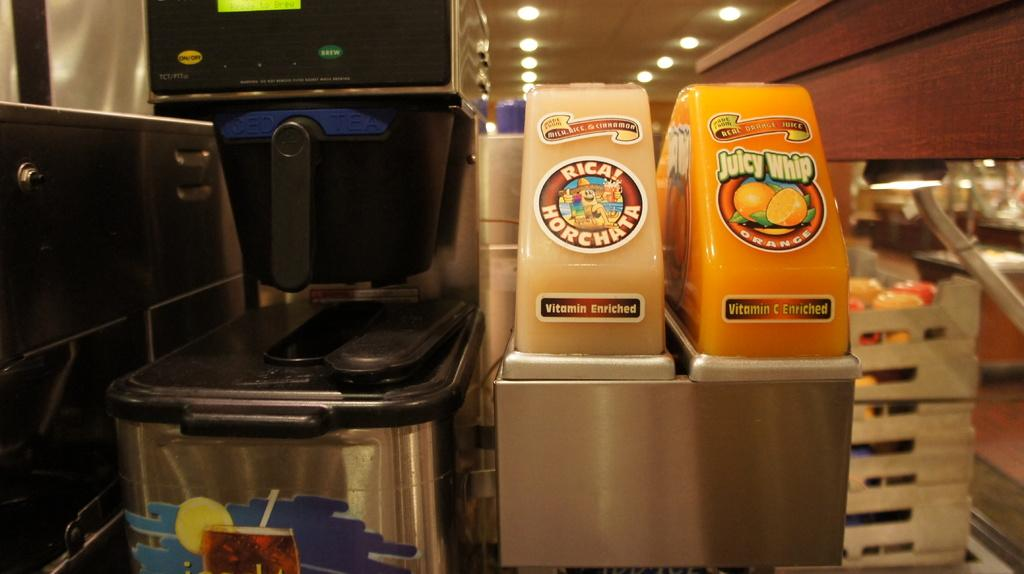<image>
Offer a succinct explanation of the picture presented. a display of Rica Horchat and Juicy Whip in a store 